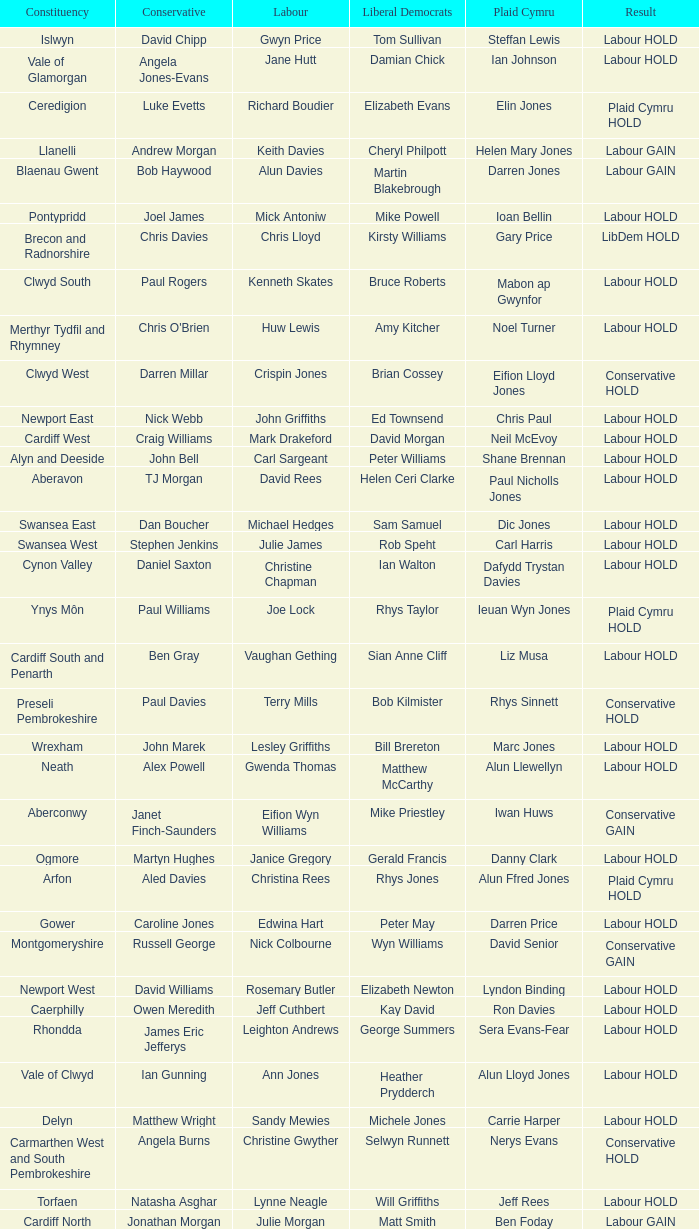What constituency does the Conservative Darren Millar belong to? Clwyd West. Parse the table in full. {'header': ['Constituency', 'Conservative', 'Labour', 'Liberal Democrats', 'Plaid Cymru', 'Result'], 'rows': [['Islwyn', 'David Chipp', 'Gwyn Price', 'Tom Sullivan', 'Steffan Lewis', 'Labour HOLD'], ['Vale of Glamorgan', 'Angela Jones-Evans', 'Jane Hutt', 'Damian Chick', 'Ian Johnson', 'Labour HOLD'], ['Ceredigion', 'Luke Evetts', 'Richard Boudier', 'Elizabeth Evans', 'Elin Jones', 'Plaid Cymru HOLD'], ['Llanelli', 'Andrew Morgan', 'Keith Davies', 'Cheryl Philpott', 'Helen Mary Jones', 'Labour GAIN'], ['Blaenau Gwent', 'Bob Haywood', 'Alun Davies', 'Martin Blakebrough', 'Darren Jones', 'Labour GAIN'], ['Pontypridd', 'Joel James', 'Mick Antoniw', 'Mike Powell', 'Ioan Bellin', 'Labour HOLD'], ['Brecon and Radnorshire', 'Chris Davies', 'Chris Lloyd', 'Kirsty Williams', 'Gary Price', 'LibDem HOLD'], ['Clwyd South', 'Paul Rogers', 'Kenneth Skates', 'Bruce Roberts', 'Mabon ap Gwynfor', 'Labour HOLD'], ['Merthyr Tydfil and Rhymney', "Chris O'Brien", 'Huw Lewis', 'Amy Kitcher', 'Noel Turner', 'Labour HOLD'], ['Clwyd West', 'Darren Millar', 'Crispin Jones', 'Brian Cossey', 'Eifion Lloyd Jones', 'Conservative HOLD'], ['Newport East', 'Nick Webb', 'John Griffiths', 'Ed Townsend', 'Chris Paul', 'Labour HOLD'], ['Cardiff West', 'Craig Williams', 'Mark Drakeford', 'David Morgan', 'Neil McEvoy', 'Labour HOLD'], ['Alyn and Deeside', 'John Bell', 'Carl Sargeant', 'Peter Williams', 'Shane Brennan', 'Labour HOLD'], ['Aberavon', 'TJ Morgan', 'David Rees', 'Helen Ceri Clarke', 'Paul Nicholls Jones', 'Labour HOLD'], ['Swansea East', 'Dan Boucher', 'Michael Hedges', 'Sam Samuel', 'Dic Jones', 'Labour HOLD'], ['Swansea West', 'Stephen Jenkins', 'Julie James', 'Rob Speht', 'Carl Harris', 'Labour HOLD'], ['Cynon Valley', 'Daniel Saxton', 'Christine Chapman', 'Ian Walton', 'Dafydd Trystan Davies', 'Labour HOLD'], ['Ynys Môn', 'Paul Williams', 'Joe Lock', 'Rhys Taylor', 'Ieuan Wyn Jones', 'Plaid Cymru HOLD'], ['Cardiff South and Penarth', 'Ben Gray', 'Vaughan Gething', 'Sian Anne Cliff', 'Liz Musa', 'Labour HOLD'], ['Preseli Pembrokeshire', 'Paul Davies', 'Terry Mills', 'Bob Kilmister', 'Rhys Sinnett', 'Conservative HOLD'], ['Wrexham', 'John Marek', 'Lesley Griffiths', 'Bill Brereton', 'Marc Jones', 'Labour HOLD'], ['Neath', 'Alex Powell', 'Gwenda Thomas', 'Matthew McCarthy', 'Alun Llewellyn', 'Labour HOLD'], ['Aberconwy', 'Janet Finch-Saunders', 'Eifion Wyn Williams', 'Mike Priestley', 'Iwan Huws', 'Conservative GAIN'], ['Ogmore', 'Martyn Hughes', 'Janice Gregory', 'Gerald Francis', 'Danny Clark', 'Labour HOLD'], ['Arfon', 'Aled Davies', 'Christina Rees', 'Rhys Jones', 'Alun Ffred Jones', 'Plaid Cymru HOLD'], ['Gower', 'Caroline Jones', 'Edwina Hart', 'Peter May', 'Darren Price', 'Labour HOLD'], ['Montgomeryshire', 'Russell George', 'Nick Colbourne', 'Wyn Williams', 'David Senior', 'Conservative GAIN'], ['Newport West', 'David Williams', 'Rosemary Butler', 'Elizabeth Newton', 'Lyndon Binding', 'Labour HOLD'], ['Caerphilly', 'Owen Meredith', 'Jeff Cuthbert', 'Kay David', 'Ron Davies', 'Labour HOLD'], ['Rhondda', 'James Eric Jefferys', 'Leighton Andrews', 'George Summers', 'Sera Evans-Fear', 'Labour HOLD'], ['Vale of Clwyd', 'Ian Gunning', 'Ann Jones', 'Heather Prydderch', 'Alun Lloyd Jones', 'Labour HOLD'], ['Delyn', 'Matthew Wright', 'Sandy Mewies', 'Michele Jones', 'Carrie Harper', 'Labour HOLD'], ['Carmarthen West and South Pembrokeshire', 'Angela Burns', 'Christine Gwyther', 'Selwyn Runnett', 'Nerys Evans', 'Conservative HOLD'], ['Torfaen', 'Natasha Asghar', 'Lynne Neagle', 'Will Griffiths', 'Jeff Rees', 'Labour HOLD'], ['Cardiff North', 'Jonathan Morgan', 'Julie Morgan', 'Matt Smith', 'Ben Foday', 'Labour GAIN'], ['Dwyfor Meirionnydd', 'Simon Baynes', 'Martyn Singleton', 'Steve Churchman', 'Lord Elis-Thomas', 'Plaid Cymru HOLD'], ['Carmarthen East and Dinefwr', 'Henrietta Hensher', 'Antony Jones', 'Will Griffiths', 'Rhodri Glyn Thomas', 'Plaid Cymru HOLD'], ['Bridgend', 'Alex Williams', 'Carwyn Jones', 'Briony Davies', 'Tim Thomas', 'Labour HOLD'], ['Monmouth', 'Nick Ramsay', 'Mark Whitcutt', 'Janet Ellard', 'Fiona Cross', 'Conservative HOLD'], ['Cardiff Central', 'Matt Smith', 'Jenny Rathbone', 'Nigel Howells', 'Chris Williams', 'Labour GAIN']]} 